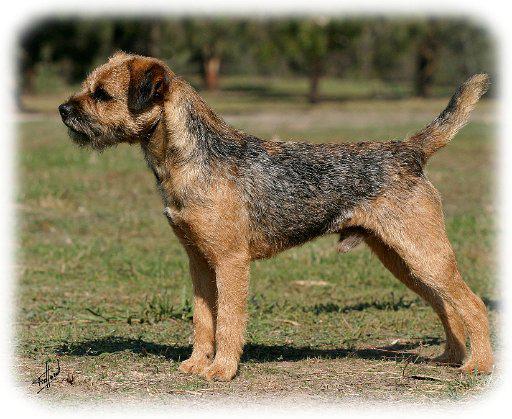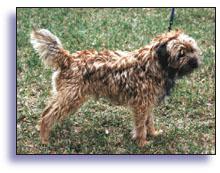The first image is the image on the left, the second image is the image on the right. Considering the images on both sides, is "In the image to the right, all dogs are standing up." valid? Answer yes or no. Yes. 